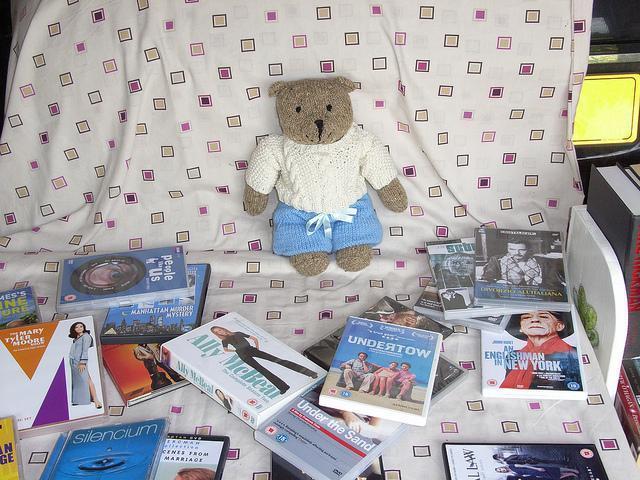How many books are in the photo?
Give a very brief answer. 14. How many chairs are there?
Give a very brief answer. 2. How many young elephants are there?
Give a very brief answer. 0. 